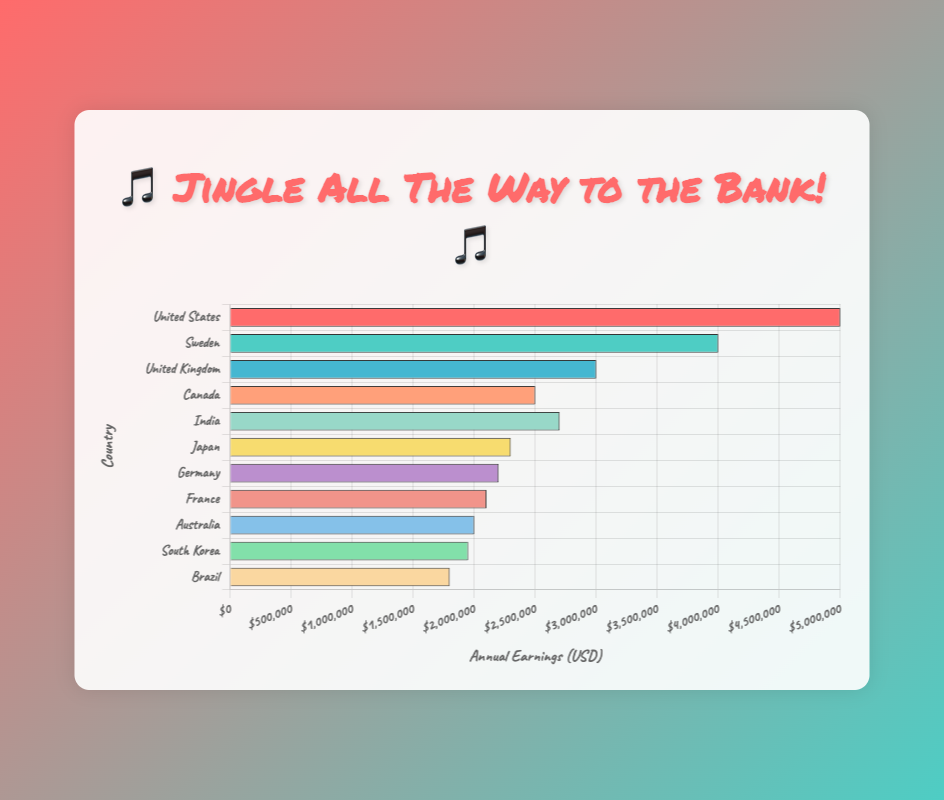What's the total annual earnings of the top three highest-earning jingle composers? To find the total annual earnings of the top three, we add the earnings of Barry Manilow (USD 5,000,000), Max Martin (USD 4,000,000), and Tony Hatch (USD 3,000,000). That gives us 5,000,000 + 4,000,000 + 3,000,000 = 12,000,000.
Answer: 12,000,000 How much more does Barry Manilow earn annually compared to Tony Hatch? Barry Manilow earns USD 5,000,000 annually, and Tony Hatch earns USD 3,000,000 annually. The difference is 5,000,000 - 3,000,000 = 2,000,000.
Answer: 2,000,000 Which composer from outside the United States has the highest annual earnings? Among the composers from outside the United States, Max Martin from Sweden has the highest annual earnings at USD 4,000,000.
Answer: Max Martin Which country’s jingle composer has the lowest annual earnings? The composer with the lowest annual earnings is Roberto Carlos from Brazil, earning USD 1,800,000.
Answer: Brazil What's the combined annual earnings of all composers from Europe? The European composers are Tony Hatch (UK, USD 3,000,000), Max Martin (Sweden, USD 4,000,000), David Brandes (Germany, USD 2,200,000), and Jean-Michel Jarre (France, USD 2,100,000). The combined earnings are 3,000,000 + 4,000,000 + 2,200,000 + 2,100,000 = 11,300,000.
Answer: 11,300,000 Are there more composers earning above USD 2,500,000 or below USD 2,500,000? There are five composers earning above USD 2,500,000 (Barry Manilow, Max Martin, Tony Hatch, Dr. Elmo, and AR Rahman) and six composers earning below USD 2,500,000 (Mike Brady, David Brandes, Jean-Michel Jarre, Tetsuya Komuro, Yuhki Kuramoto, Roberto Carlos). Therefore, more composers earn below USD 2,500,000.
Answer: Below Which countries have composers earning between USD 2,000,000 and USD 3,000,000? The composers earning between USD 2,000,000 and USD 3,000,000 are from Canada (Dr. Elmo, USD 2,500,000), India (AR Rahman, USD 2,700,000), Japan (Tetsuya Komuro, USD 2,300,000), Germany (David Brandes, USD 2,200,000), and France (Jean-Michel Jarre, USD 2,100,000).
Answer: Canada, India, Japan, Germany, France What's the average annual earnings of composers from Asia? The Asian composers are Tetsuya Komuro (Japan, USD 2,300,000), AR Rahman (India, USD 2,700,000), and Yuhki Kuramoto (South Korea, USD 1,950,000). The total is 2,300,000 + 2,700,000 + 1,950,000 = 6,950,000. The average is 6,950,000 / 3 = 2,316,667.
Answer: 2,316,667 What's the difference in annual earnings between the composer from Brazil and the composer from South Korea? The composer from Brazil (Roberto Carlos) earns USD 1,800,000 annually, and the composer from South Korea (Yuhki Kuramoto) earns USD 1,950,000 annually. The difference is 1,950,000 - 1,800,000 = 150,000.
Answer: 150,000 Which composer's bar is colored red, and what are their annual earnings? Barry Manilow’s bar is colored red, and his annual earnings are USD 5,000,000.
Answer: Barry Manilow, 5,000,000 